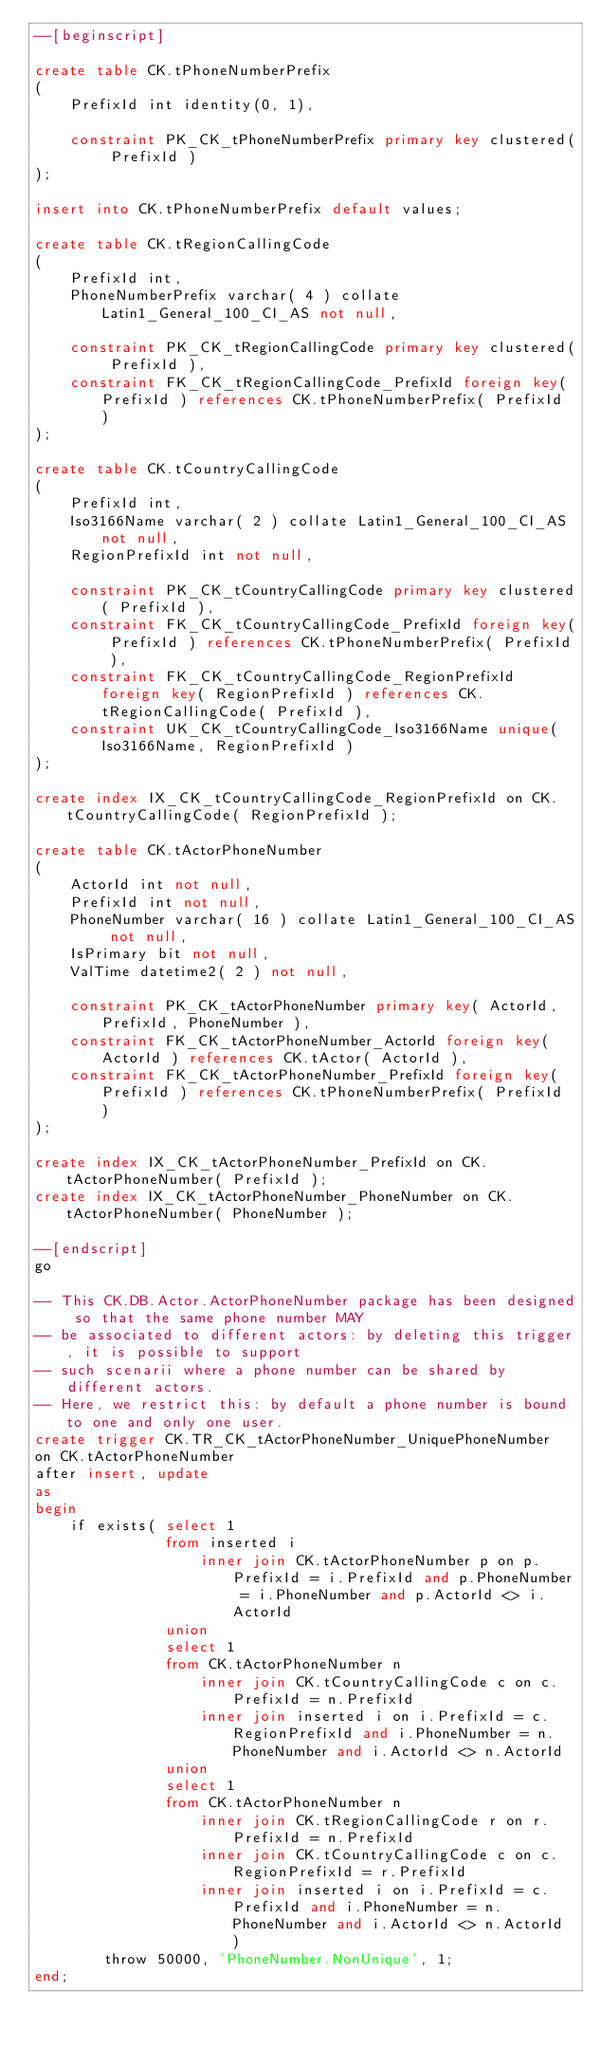<code> <loc_0><loc_0><loc_500><loc_500><_SQL_>--[beginscript]

create table CK.tPhoneNumberPrefix
(
    PrefixId int identity(0, 1),

    constraint PK_CK_tPhoneNumberPrefix primary key clustered( PrefixId )
);

insert into CK.tPhoneNumberPrefix default values;

create table CK.tRegionCallingCode
(
    PrefixId int,
    PhoneNumberPrefix varchar( 4 ) collate Latin1_General_100_CI_AS not null,

    constraint PK_CK_tRegionCallingCode primary key clustered( PrefixId ),
    constraint FK_CK_tRegionCallingCode_PrefixId foreign key( PrefixId ) references CK.tPhoneNumberPrefix( PrefixId )
);

create table CK.tCountryCallingCode
(
    PrefixId int,
    Iso3166Name varchar( 2 ) collate Latin1_General_100_CI_AS not null,
    RegionPrefixId int not null,

    constraint PK_CK_tCountryCallingCode primary key clustered( PrefixId ),
    constraint FK_CK_tCountryCallingCode_PrefixId foreign key( PrefixId ) references CK.tPhoneNumberPrefix( PrefixId ),
    constraint FK_CK_tCountryCallingCode_RegionPrefixId foreign key( RegionPrefixId ) references CK.tRegionCallingCode( PrefixId ),
    constraint UK_CK_tCountryCallingCode_Iso3166Name unique( Iso3166Name, RegionPrefixId )
);

create index IX_CK_tCountryCallingCode_RegionPrefixId on CK.tCountryCallingCode( RegionPrefixId );

create table CK.tActorPhoneNumber
(
	ActorId int not null,
    PrefixId int not null,
	PhoneNumber varchar( 16 ) collate Latin1_General_100_CI_AS not null,
	IsPrimary bit not null,
	ValTime datetime2( 2 ) not null,

	constraint PK_CK_tActorPhoneNumber primary key( ActorId, PrefixId, PhoneNumber ),
	constraint FK_CK_tActorPhoneNumber_ActorId foreign key( ActorId ) references CK.tActor( ActorId ),
    constraint FK_CK_tActorPhoneNumber_PrefixId foreign key( PrefixId ) references CK.tPhoneNumberPrefix( PrefixId )
);

create index IX_CK_tActorPhoneNumber_PrefixId on CK.tActorPhoneNumber( PrefixId );
create index IX_CK_tActorPhoneNumber_PhoneNumber on CK.tActorPhoneNumber( PhoneNumber );

--[endscript]
go

-- This CK.DB.Actor.ActorPhoneNumber package has been designed so that the same phone number MAY
-- be associated to different actors: by deleting this trigger, it is possible to support
-- such scenarii where a phone number can be shared by different actors.
-- Here, we restrict this: by default a phone number is bound to one and only one user.
create trigger CK.TR_CK_tActorPhoneNumber_UniquePhoneNumber
on CK.tActorPhoneNumber
after insert, update
as
begin
    if exists( select 1
               from inserted i
                   inner join CK.tActorPhoneNumber p on p.PrefixId = i.PrefixId and p.PhoneNumber = i.PhoneNumber and p.ActorId <> i.ActorId
               union
               select 1
               from CK.tActorPhoneNumber n
                   inner join CK.tCountryCallingCode c on c.PrefixId = n.PrefixId
                   inner join inserted i on i.PrefixId = c.RegionPrefixId and i.PhoneNumber = n.PhoneNumber and i.ActorId <> n.ActorId
               union
               select 1
               from CK.tActorPhoneNumber n
                   inner join CK.tRegionCallingCode r on r.PrefixId = n.PrefixId
                   inner join CK.tCountryCallingCode c on c.RegionPrefixId = r.PrefixId
                   inner join inserted i on i.PrefixId = c.PrefixId and i.PhoneNumber = n.PhoneNumber and i.ActorId <> n.ActorId )
        throw 50000, 'PhoneNumber.NonUnique', 1;
end;


</code> 